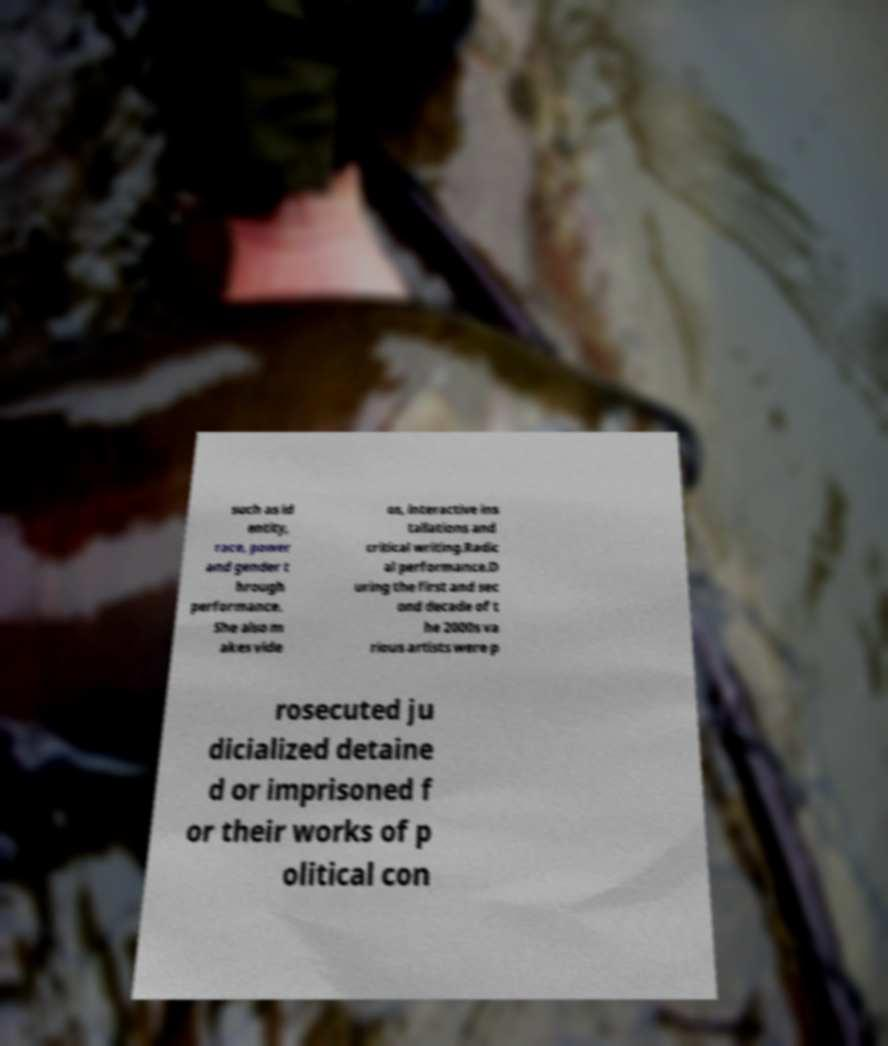Could you extract and type out the text from this image? such as id entity, race, power and gender t hrough performance. She also m akes vide os, interactive ins tallations and critical writing.Radic al performance.D uring the first and sec ond decade of t he 2000s va rious artists were p rosecuted ju dicialized detaine d or imprisoned f or their works of p olitical con 